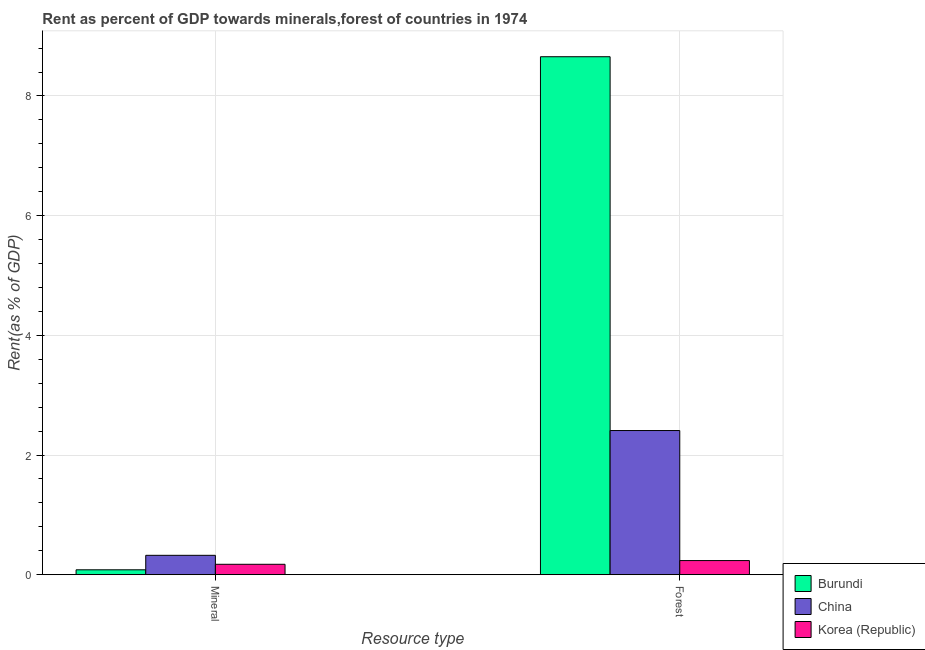How many groups of bars are there?
Offer a terse response. 2. Are the number of bars per tick equal to the number of legend labels?
Ensure brevity in your answer.  Yes. Are the number of bars on each tick of the X-axis equal?
Offer a very short reply. Yes. How many bars are there on the 1st tick from the right?
Provide a short and direct response. 3. What is the label of the 2nd group of bars from the left?
Keep it short and to the point. Forest. What is the mineral rent in Burundi?
Your response must be concise. 0.08. Across all countries, what is the maximum forest rent?
Keep it short and to the point. 8.66. Across all countries, what is the minimum forest rent?
Offer a terse response. 0.24. In which country was the mineral rent maximum?
Offer a terse response. China. In which country was the mineral rent minimum?
Your answer should be very brief. Burundi. What is the total forest rent in the graph?
Keep it short and to the point. 11.3. What is the difference between the forest rent in Burundi and that in Korea (Republic)?
Your answer should be very brief. 8.42. What is the difference between the mineral rent in Burundi and the forest rent in Korea (Republic)?
Offer a very short reply. -0.15. What is the average forest rent per country?
Offer a terse response. 3.77. What is the difference between the mineral rent and forest rent in Burundi?
Keep it short and to the point. -8.57. What is the ratio of the mineral rent in China to that in Korea (Republic)?
Provide a short and direct response. 1.86. How many bars are there?
Give a very brief answer. 6. What is the difference between two consecutive major ticks on the Y-axis?
Provide a succinct answer. 2. Are the values on the major ticks of Y-axis written in scientific E-notation?
Offer a terse response. No. Does the graph contain grids?
Your answer should be compact. Yes. How many legend labels are there?
Your answer should be compact. 3. How are the legend labels stacked?
Provide a succinct answer. Vertical. What is the title of the graph?
Provide a short and direct response. Rent as percent of GDP towards minerals,forest of countries in 1974. Does "Rwanda" appear as one of the legend labels in the graph?
Your response must be concise. No. What is the label or title of the X-axis?
Offer a very short reply. Resource type. What is the label or title of the Y-axis?
Keep it short and to the point. Rent(as % of GDP). What is the Rent(as % of GDP) of Burundi in Mineral?
Your response must be concise. 0.08. What is the Rent(as % of GDP) in China in Mineral?
Provide a short and direct response. 0.32. What is the Rent(as % of GDP) of Korea (Republic) in Mineral?
Make the answer very short. 0.17. What is the Rent(as % of GDP) in Burundi in Forest?
Provide a short and direct response. 8.66. What is the Rent(as % of GDP) in China in Forest?
Provide a succinct answer. 2.41. What is the Rent(as % of GDP) in Korea (Republic) in Forest?
Your answer should be very brief. 0.24. Across all Resource type, what is the maximum Rent(as % of GDP) of Burundi?
Provide a short and direct response. 8.66. Across all Resource type, what is the maximum Rent(as % of GDP) in China?
Make the answer very short. 2.41. Across all Resource type, what is the maximum Rent(as % of GDP) of Korea (Republic)?
Offer a very short reply. 0.24. Across all Resource type, what is the minimum Rent(as % of GDP) of Burundi?
Your answer should be compact. 0.08. Across all Resource type, what is the minimum Rent(as % of GDP) of China?
Offer a very short reply. 0.32. Across all Resource type, what is the minimum Rent(as % of GDP) in Korea (Republic)?
Ensure brevity in your answer.  0.17. What is the total Rent(as % of GDP) of Burundi in the graph?
Offer a very short reply. 8.74. What is the total Rent(as % of GDP) of China in the graph?
Keep it short and to the point. 2.73. What is the total Rent(as % of GDP) in Korea (Republic) in the graph?
Make the answer very short. 0.41. What is the difference between the Rent(as % of GDP) in Burundi in Mineral and that in Forest?
Keep it short and to the point. -8.57. What is the difference between the Rent(as % of GDP) in China in Mineral and that in Forest?
Ensure brevity in your answer.  -2.09. What is the difference between the Rent(as % of GDP) of Korea (Republic) in Mineral and that in Forest?
Your answer should be very brief. -0.06. What is the difference between the Rent(as % of GDP) of Burundi in Mineral and the Rent(as % of GDP) of China in Forest?
Your answer should be very brief. -2.33. What is the difference between the Rent(as % of GDP) in Burundi in Mineral and the Rent(as % of GDP) in Korea (Republic) in Forest?
Provide a succinct answer. -0.15. What is the difference between the Rent(as % of GDP) of China in Mineral and the Rent(as % of GDP) of Korea (Republic) in Forest?
Offer a very short reply. 0.09. What is the average Rent(as % of GDP) in Burundi per Resource type?
Your answer should be very brief. 4.37. What is the average Rent(as % of GDP) in China per Resource type?
Provide a succinct answer. 1.37. What is the average Rent(as % of GDP) in Korea (Republic) per Resource type?
Provide a short and direct response. 0.2. What is the difference between the Rent(as % of GDP) in Burundi and Rent(as % of GDP) in China in Mineral?
Ensure brevity in your answer.  -0.24. What is the difference between the Rent(as % of GDP) in Burundi and Rent(as % of GDP) in Korea (Republic) in Mineral?
Your answer should be compact. -0.09. What is the difference between the Rent(as % of GDP) in China and Rent(as % of GDP) in Korea (Republic) in Mineral?
Your answer should be very brief. 0.15. What is the difference between the Rent(as % of GDP) of Burundi and Rent(as % of GDP) of China in Forest?
Keep it short and to the point. 6.25. What is the difference between the Rent(as % of GDP) in Burundi and Rent(as % of GDP) in Korea (Republic) in Forest?
Offer a terse response. 8.42. What is the difference between the Rent(as % of GDP) of China and Rent(as % of GDP) of Korea (Republic) in Forest?
Your response must be concise. 2.17. What is the ratio of the Rent(as % of GDP) of Burundi in Mineral to that in Forest?
Your answer should be compact. 0.01. What is the ratio of the Rent(as % of GDP) in China in Mineral to that in Forest?
Make the answer very short. 0.13. What is the ratio of the Rent(as % of GDP) in Korea (Republic) in Mineral to that in Forest?
Keep it short and to the point. 0.74. What is the difference between the highest and the second highest Rent(as % of GDP) of Burundi?
Offer a terse response. 8.57. What is the difference between the highest and the second highest Rent(as % of GDP) of China?
Provide a succinct answer. 2.09. What is the difference between the highest and the second highest Rent(as % of GDP) of Korea (Republic)?
Make the answer very short. 0.06. What is the difference between the highest and the lowest Rent(as % of GDP) of Burundi?
Offer a very short reply. 8.57. What is the difference between the highest and the lowest Rent(as % of GDP) in China?
Offer a terse response. 2.09. What is the difference between the highest and the lowest Rent(as % of GDP) of Korea (Republic)?
Offer a very short reply. 0.06. 